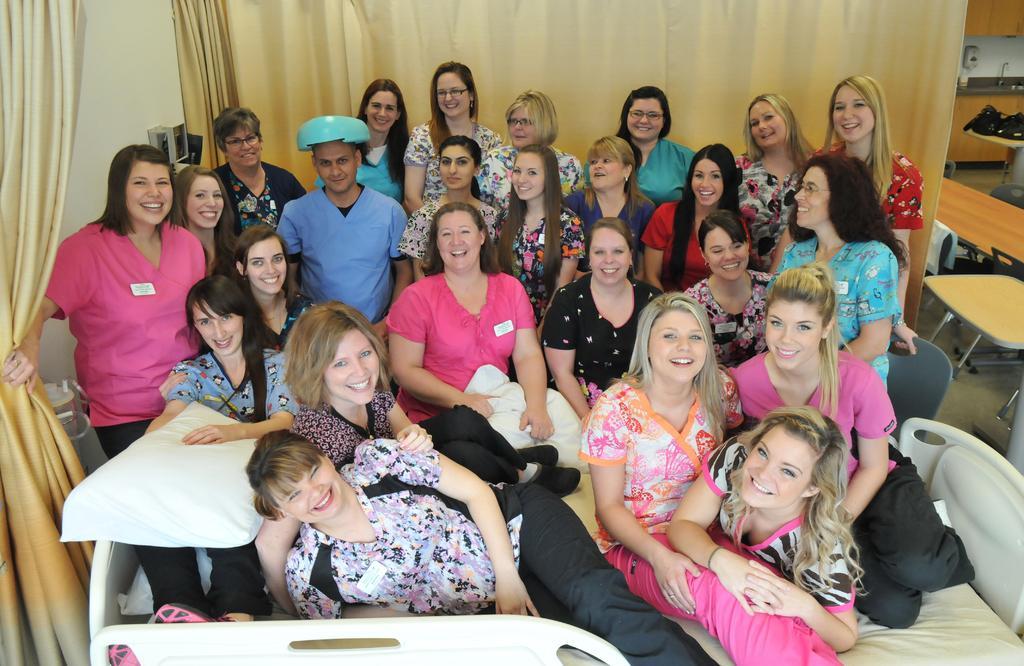In one or two sentences, can you explain what this image depicts? In this picture there is a women who is wearing pink shirt and trouser and holding a pillow. Beside her we can see a man who is wearing blue t-shirt. On the right we can see the group of women were sitting on the chair. On the left we can see another group of persons were sitting on the bed. In the back we can see the cloth. 